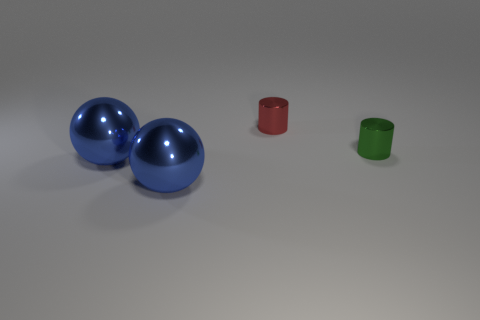Are there any other things that have the same shape as the green object?
Give a very brief answer. Yes. What number of things are either green shiny cylinders or objects on the left side of the tiny green metallic cylinder?
Make the answer very short. 4. What number of other things are there of the same material as the small red cylinder
Offer a very short reply. 3. What number of objects are cylinders or big metallic spheres?
Offer a very short reply. 4. Are there more shiny objects behind the green metal cylinder than blue metal spheres behind the small red metallic cylinder?
Make the answer very short. Yes. What size is the red cylinder that is left of the green cylinder that is in front of the small shiny cylinder on the left side of the tiny green cylinder?
Make the answer very short. Small. There is another tiny object that is the same shape as the small red thing; what color is it?
Provide a succinct answer. Green. Are there more tiny green things on the right side of the tiny red metallic cylinder than tiny cyan rubber objects?
Keep it short and to the point. Yes. There is a tiny red metal object; does it have the same shape as the small object that is to the right of the red metallic thing?
Make the answer very short. Yes. Is the number of blue spheres greater than the number of yellow rubber cylinders?
Provide a succinct answer. Yes. 